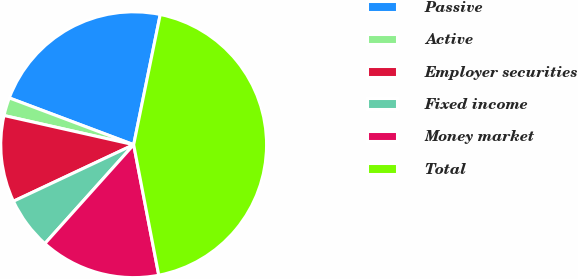Convert chart to OTSL. <chart><loc_0><loc_0><loc_500><loc_500><pie_chart><fcel>Passive<fcel>Active<fcel>Employer securities<fcel>Fixed income<fcel>Money market<fcel>Total<nl><fcel>22.48%<fcel>2.2%<fcel>10.52%<fcel>6.36%<fcel>14.67%<fcel>43.77%<nl></chart> 